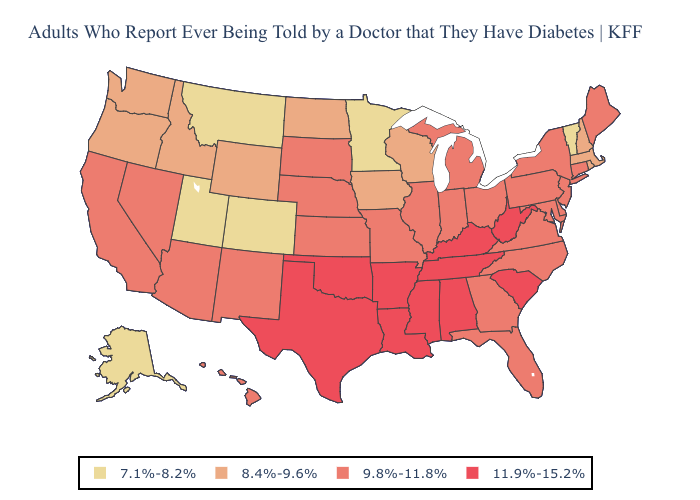Which states have the lowest value in the Northeast?
Short answer required. Vermont. Name the states that have a value in the range 7.1%-8.2%?
Keep it brief. Alaska, Colorado, Minnesota, Montana, Utah, Vermont. Which states have the highest value in the USA?
Write a very short answer. Alabama, Arkansas, Kentucky, Louisiana, Mississippi, Oklahoma, South Carolina, Tennessee, Texas, West Virginia. Does California have a higher value than Oklahoma?
Keep it brief. No. What is the value of Nebraska?
Keep it brief. 9.8%-11.8%. Does the map have missing data?
Keep it brief. No. Does Utah have the lowest value in the West?
Keep it brief. Yes. Name the states that have a value in the range 9.8%-11.8%?
Be succinct. Arizona, California, Connecticut, Delaware, Florida, Georgia, Hawaii, Illinois, Indiana, Kansas, Maine, Maryland, Michigan, Missouri, Nebraska, Nevada, New Jersey, New Mexico, New York, North Carolina, Ohio, Pennsylvania, South Dakota, Virginia. Which states have the lowest value in the USA?
Answer briefly. Alaska, Colorado, Minnesota, Montana, Utah, Vermont. What is the lowest value in the West?
Concise answer only. 7.1%-8.2%. What is the value of Utah?
Short answer required. 7.1%-8.2%. What is the value of Minnesota?
Keep it brief. 7.1%-8.2%. Does Georgia have a higher value than Vermont?
Be succinct. Yes. Does Louisiana have the highest value in the USA?
Be succinct. Yes. Name the states that have a value in the range 11.9%-15.2%?
Concise answer only. Alabama, Arkansas, Kentucky, Louisiana, Mississippi, Oklahoma, South Carolina, Tennessee, Texas, West Virginia. 